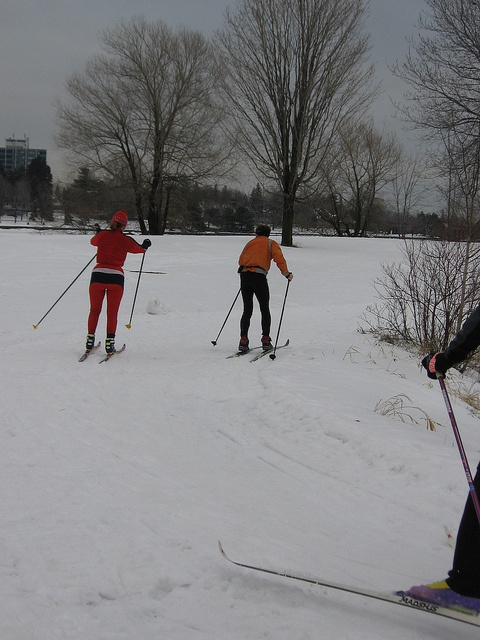Describe the objects in this image and their specific colors. I can see people in gray, maroon, black, and darkgray tones, people in gray, black, and navy tones, people in gray, black, maroon, and darkgray tones, skis in gray, darkgray, and black tones, and skis in gray, darkgray, and black tones in this image. 